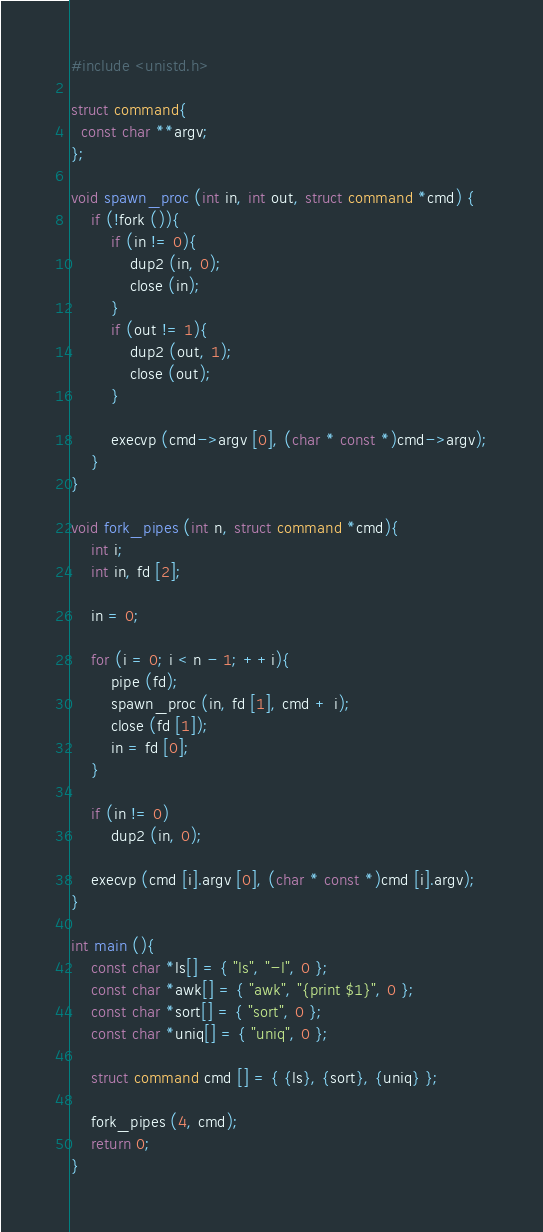Convert code to text. <code><loc_0><loc_0><loc_500><loc_500><_C_>#include <unistd.h>

struct command{
  const char **argv;
};

void spawn_proc (int in, int out, struct command *cmd) {
 	if (!fork ()){
		if (in != 0){
			dup2 (in, 0);
			close (in);
		}
		if (out != 1){
			dup2 (out, 1);
			close (out);
		}

		execvp (cmd->argv [0], (char * const *)cmd->argv);
	}
}

void fork_pipes (int n, struct command *cmd){
	int i;
	int in, fd [2];

	in = 0;

	for (i = 0; i < n - 1; ++i){
		pipe (fd);
		spawn_proc (in, fd [1], cmd + i);
		close (fd [1]);
		in = fd [0];
	}

	if (in != 0)
		dup2 (in, 0);

	execvp (cmd [i].argv [0], (char * const *)cmd [i].argv);
}

int main (){
	const char *ls[] = { "ls", "-l", 0 };
	const char *awk[] = { "awk", "{print $1}", 0 };
	const char *sort[] = { "sort", 0 };
	const char *uniq[] = { "uniq", 0 };

	struct command cmd [] = { {ls}, {sort}, {uniq} };

	fork_pipes (4, cmd);
	return 0;
}</code> 